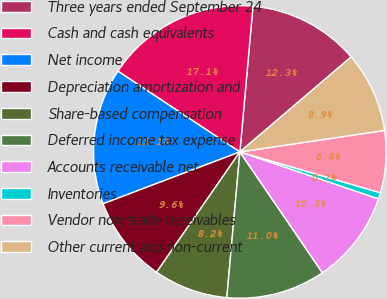<chart> <loc_0><loc_0><loc_500><loc_500><pie_chart><fcel>Three years ended September 24<fcel>Cash and cash equivalents<fcel>Net income<fcel>Depreciation amortization and<fcel>Share-based compensation<fcel>Deferred income tax expense<fcel>Accounts receivable net<fcel>Inventories<fcel>Vendor non-trade receivables<fcel>Other current and non-current<nl><fcel>12.33%<fcel>17.12%<fcel>15.07%<fcel>9.59%<fcel>8.22%<fcel>10.96%<fcel>10.27%<fcel>0.69%<fcel>6.85%<fcel>8.9%<nl></chart> 